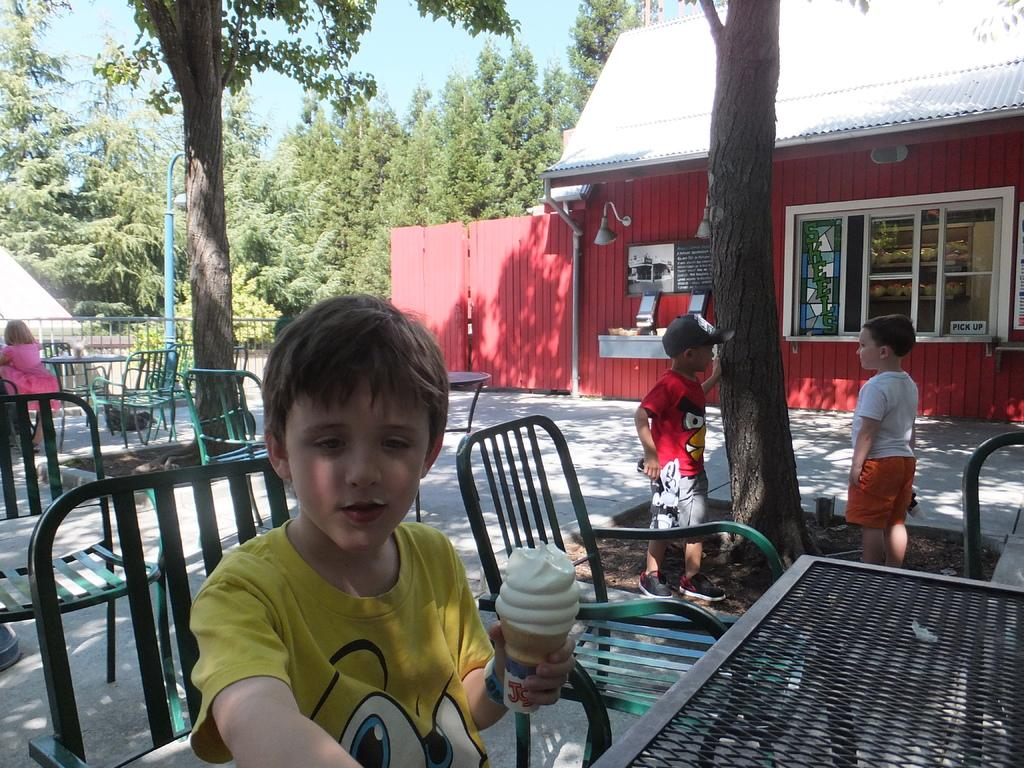What type of vegetation can be seen in the image? There are trees in the image. What type of structure is visible in the image? There is a house in the image. What architectural feature is present in the house? There is a window in the image. What type of furniture is present in the image? There are tables and chairs in the image. Who is present in the image? A boy is sitting in the image. What is the boy holding in the image? The boy is holding ice cream in the image. What type of cracker is the minister holding in the image? There is no minister or cracker present in the image. How many quinces are visible on the table in the image? There are no quinces present in the image. 